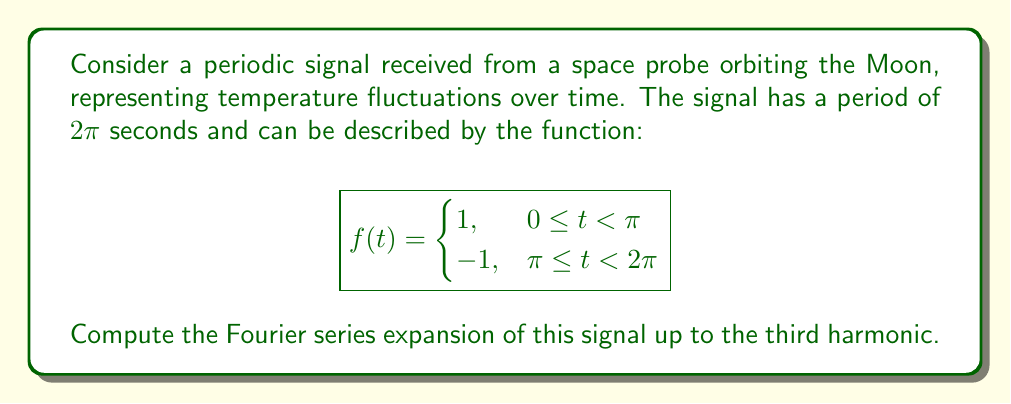Could you help me with this problem? Let's approach this step-by-step:

1) The general form of a Fourier series is:

   $$f(t) = \frac{a_0}{2} + \sum_{n=1}^{\infty} (a_n \cos(n\omega t) + b_n \sin(n\omega t))$$

   where $\omega = \frac{2\pi}{T} = 1$ (since $T = 2\pi$).

2) We need to calculate $a_0$, $a_n$, and $b_n$:

   $$a_0 = \frac{1}{\pi} \int_0^{2\pi} f(t) dt$$
   $$a_n = \frac{1}{\pi} \int_0^{2\pi} f(t) \cos(nt) dt$$
   $$b_n = \frac{1}{\pi} \int_0^{2\pi} f(t) \sin(nt) dt$$

3) Calculate $a_0$:
   $$a_0 = \frac{1}{\pi} \left(\int_0^{\pi} 1 dt + \int_{\pi}^{2\pi} (-1) dt\right) = \frac{1}{\pi} (\pi - \pi) = 0$$

4) Calculate $a_n$:
   $$a_n = \frac{1}{\pi} \left(\int_0^{\pi} \cos(nt) dt - \int_{\pi}^{2\pi} \cos(nt) dt\right)$$
   $$= \frac{1}{\pi} \left[\frac{\sin(nt)}{n}\right]_0^{\pi} - \frac{1}{\pi} \left[\frac{\sin(nt)}{n}\right]_{\pi}^{2\pi}$$
   $$= \frac{1}{\pi n} (\sin(n\pi) - \sin(0) - \sin(2n\pi) + \sin(n\pi)) = 0$$

5) Calculate $b_n$:
   $$b_n = \frac{1}{\pi} \left(\int_0^{\pi} \sin(nt) dt - \int_{\pi}^{2\pi} \sin(nt) dt\right)$$
   $$= \frac{1}{\pi} \left[-\frac{\cos(nt)}{n}\right]_0^{\pi} + \frac{1}{\pi} \left[\frac{\cos(nt)}{n}\right]_{\pi}^{2\pi}$$
   $$= \frac{1}{\pi n} (-\cos(n\pi) + 1 + \cos(2n\pi) - \cos(n\pi))$$
   $$= \frac{2}{\pi n} (1 - \cos(n\pi)) = \begin{cases}
   \frac{4}{\pi n}, & n \text{ odd} \\
   0, & n \text{ even}
   \end{cases}$$

6) Therefore, the Fourier series up to the third harmonic is:

   $$f(t) = \frac{4}{\pi} \sin(t) + \frac{4}{3\pi} \sin(3t)$$
Answer: $$f(t) = \frac{4}{\pi} \sin(t) + \frac{4}{3\pi} \sin(3t)$$ 